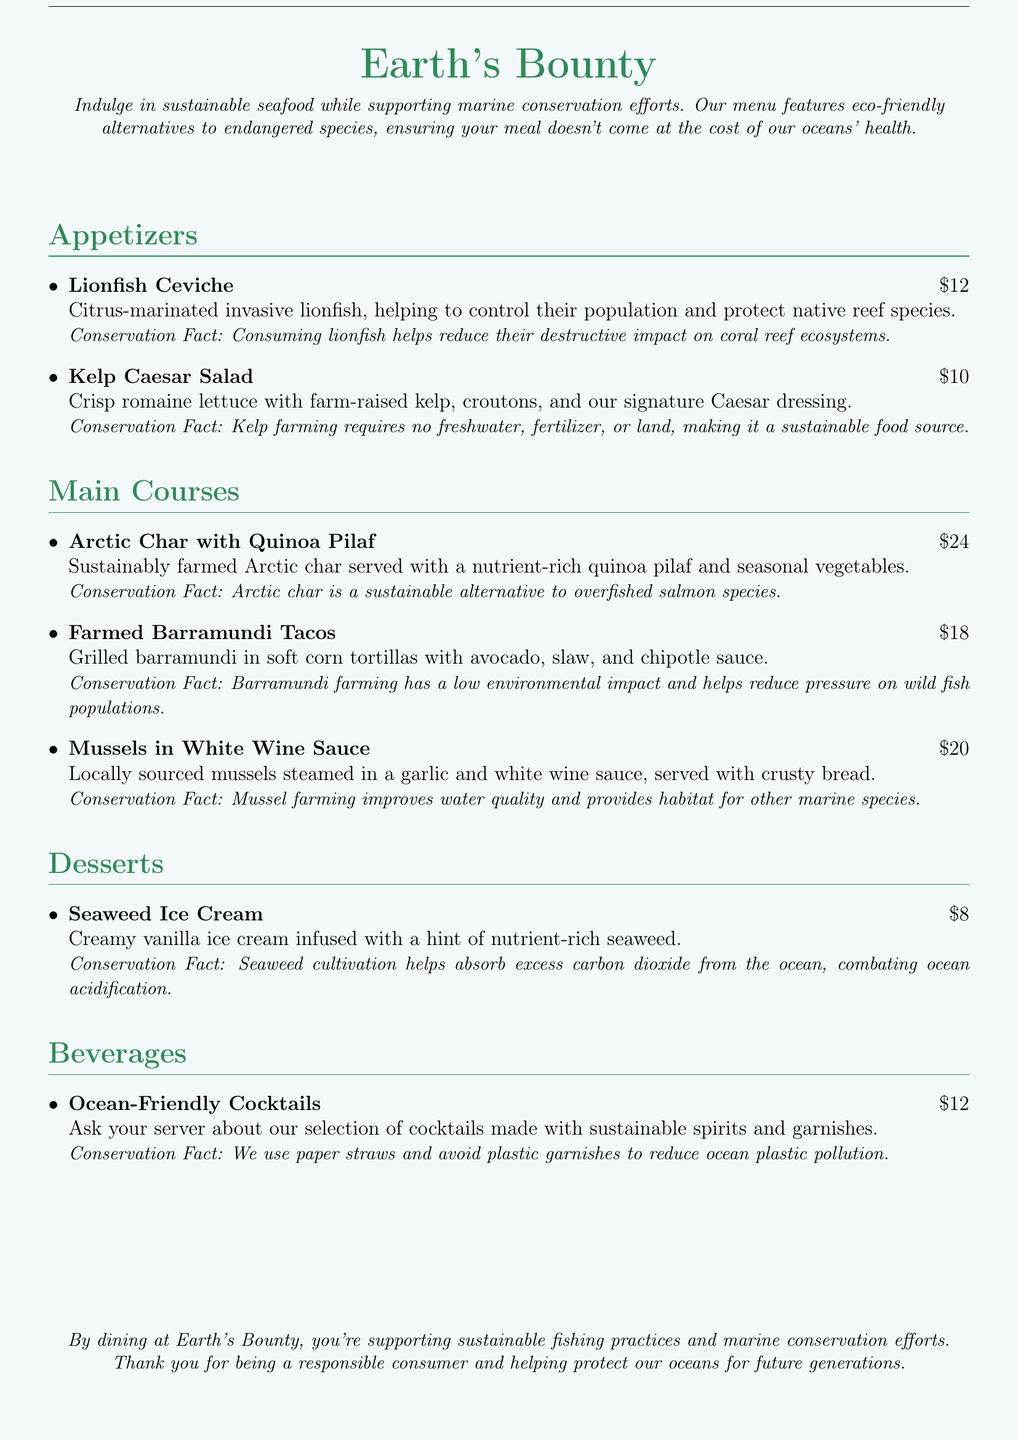What is the price of Lionfish Ceviche? The price of Lionfish Ceviche is listed under the appetizers section of the menu.
Answer: $12 What is the main ingredient of Kelp Caesar Salad? The main ingredient of Kelp Caesar Salad is farm-raised kelp mentioned in the description.
Answer: farm-raised kelp What is a conservation fact about Arctic char? The conservation fact provides information about Arctic char being a sustainable alternative to overfished salmon species.
Answer: sustainable alternative to overfished salmon species Which dessert contains seaweed? The dessert that contains seaweed is mentioned explicitly in its title and description.
Answer: Seaweed Ice Cream What are the two types of tacos mentioned in the menu? The type of tacos can be found in the main courses section specifically under the dish name.
Answer: Farmed Barramundi Tacos How much is the Seaweed Ice Cream? The price can be directly retrieved from the desserts section of the menu.
Answer: $8 What is one benefit of consuming lionfish? The benefit is highlighted in the conservation fact associated with the dish.
Answer: reduces destructive impact on coral reef ecosystems What is the environmental impact of barramundi farming? The impact is found in the conservation fact that accompanies the barramundi dish.
Answer: low environmental impact What should you ask your server regarding cocktails? This refers to information provided in the beverages section related to cocktail inquiries.
Answer: selection of cocktails made with sustainable spirits and garnishes 